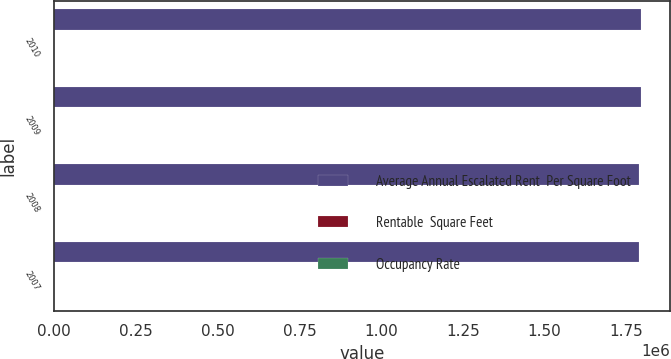Convert chart. <chart><loc_0><loc_0><loc_500><loc_500><stacked_bar_chart><ecel><fcel>2010<fcel>2009<fcel>2008<fcel>2007<nl><fcel>Average Annual Escalated Rent  Per Square Foot<fcel>1.795e+06<fcel>1.794e+06<fcel>1.789e+06<fcel>1.789e+06<nl><fcel>Rentable  Square Feet<fcel>93<fcel>94.8<fcel>94<fcel>95<nl><fcel>Occupancy Rate<fcel>55.97<fcel>57.25<fcel>57.98<fcel>59.84<nl></chart> 